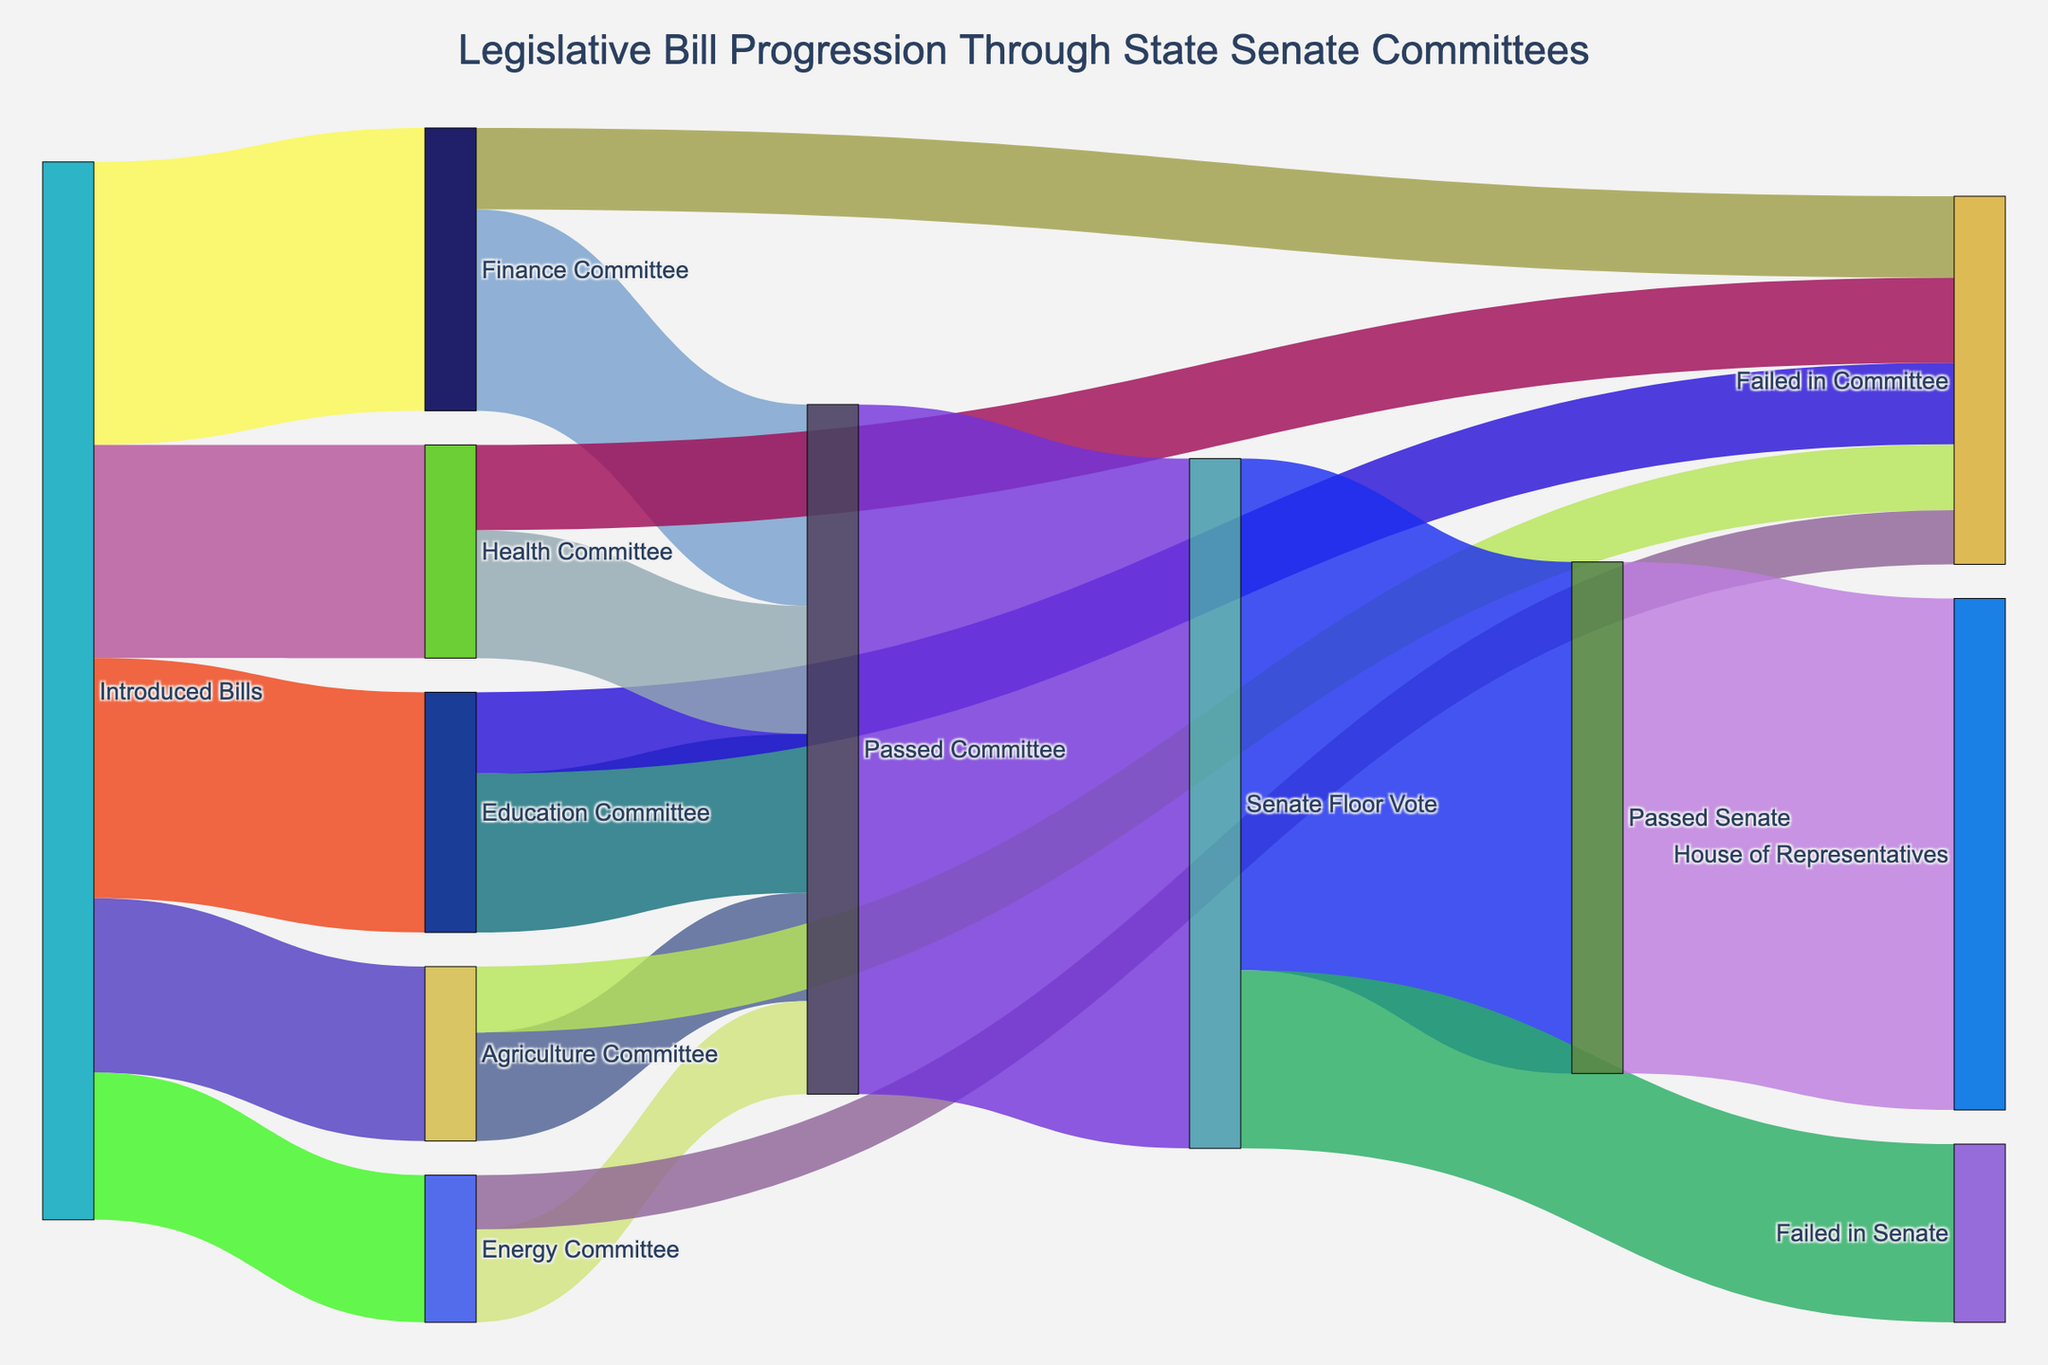What is the title of the figure? The title appears at the top of the figure and generally provides an overview of the visualized data.
Answer: Legislative Bill Progression Through State Senate Committees How many bills were initially introduced? By looking at the width of the first node labeled "Introduced Bills" and summing the flows going out of this node, we can determine the total number of introduced bills. The figure lists numbers for each committee.
Answer: 273 Which committee received the greatest number of introduced bills? We compare the numbers associated with the arrows going from "Introduced Bills" to each committee to see which is the largest.
Answer: Finance Committee How many bills from the Finance Committee passed the committee stage? Track the flow labeled 'Finance Committee' and then see how many of those go to the node 'Passed Committee'.
Answer: 52 What percentage of bills introduced to the Finance Committee passed the committee stage? Take the number of bills that passed (52) and divide it by the total bills introduced to the Finance Committee (73), then multiply by 100 to get the percentage.
Answer: 71.23% How many bills failed in the Education Committee? Follow the flow from 'Education Committee' to 'Failed in Committee'.
Answer: 21 What is the total number of bills that passed all committees? Sum the values of the flows from each committee to 'Passed Committee'.
Answer: 178 How many bills failed during the Senate Floor Vote? Track the flow from 'Senate Floor Vote' to 'Failed in Senate'.
Answer: 46 Compare the number of bills passed in the Senate versus those failed in the Senate. Which is higher? Compare the figures under 'Senate Floor Vote' going to 'Passed Senate' and 'Failed in Senate'. The larger value indicates the higher number.
Answer: Passed in Senate What percentage of bills that went to the Senate Floor Vote passed the Senate? Take the number of bills that passed the Senate (132) and divide it by the total number of bills that went to the Senate Floor Vote (178), then multiply by 100 to get the percentage.
Answer: 74.16% 